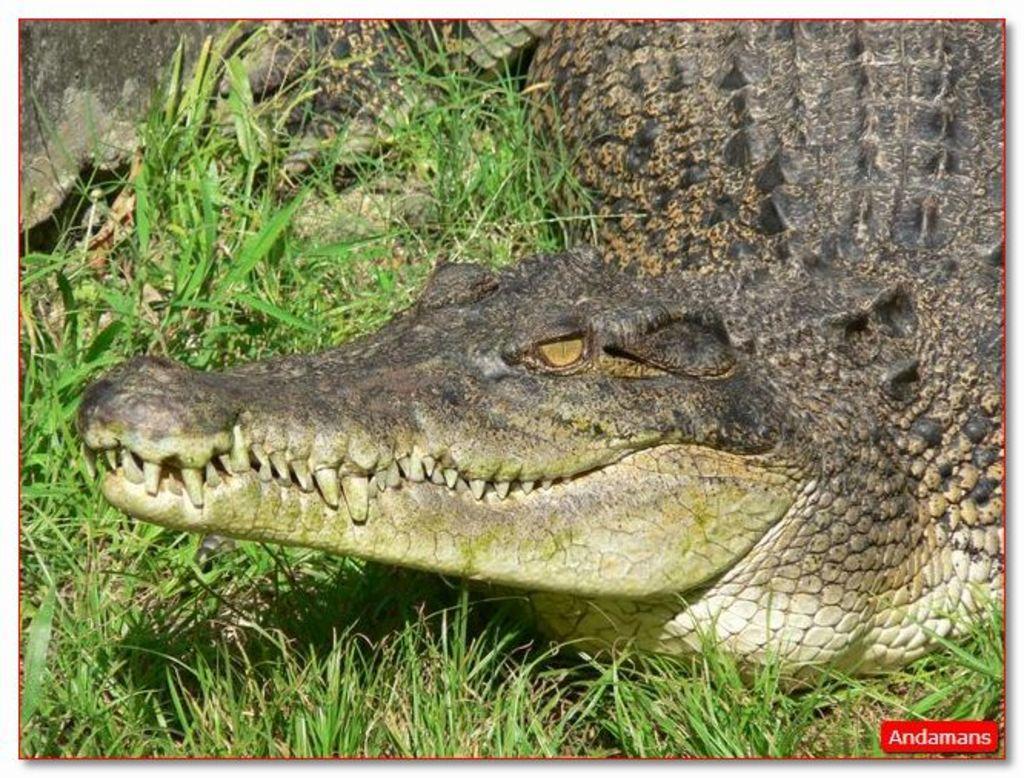Please provide a concise description of this image. In the foreground of this image, there is a crocodile on the grass. 